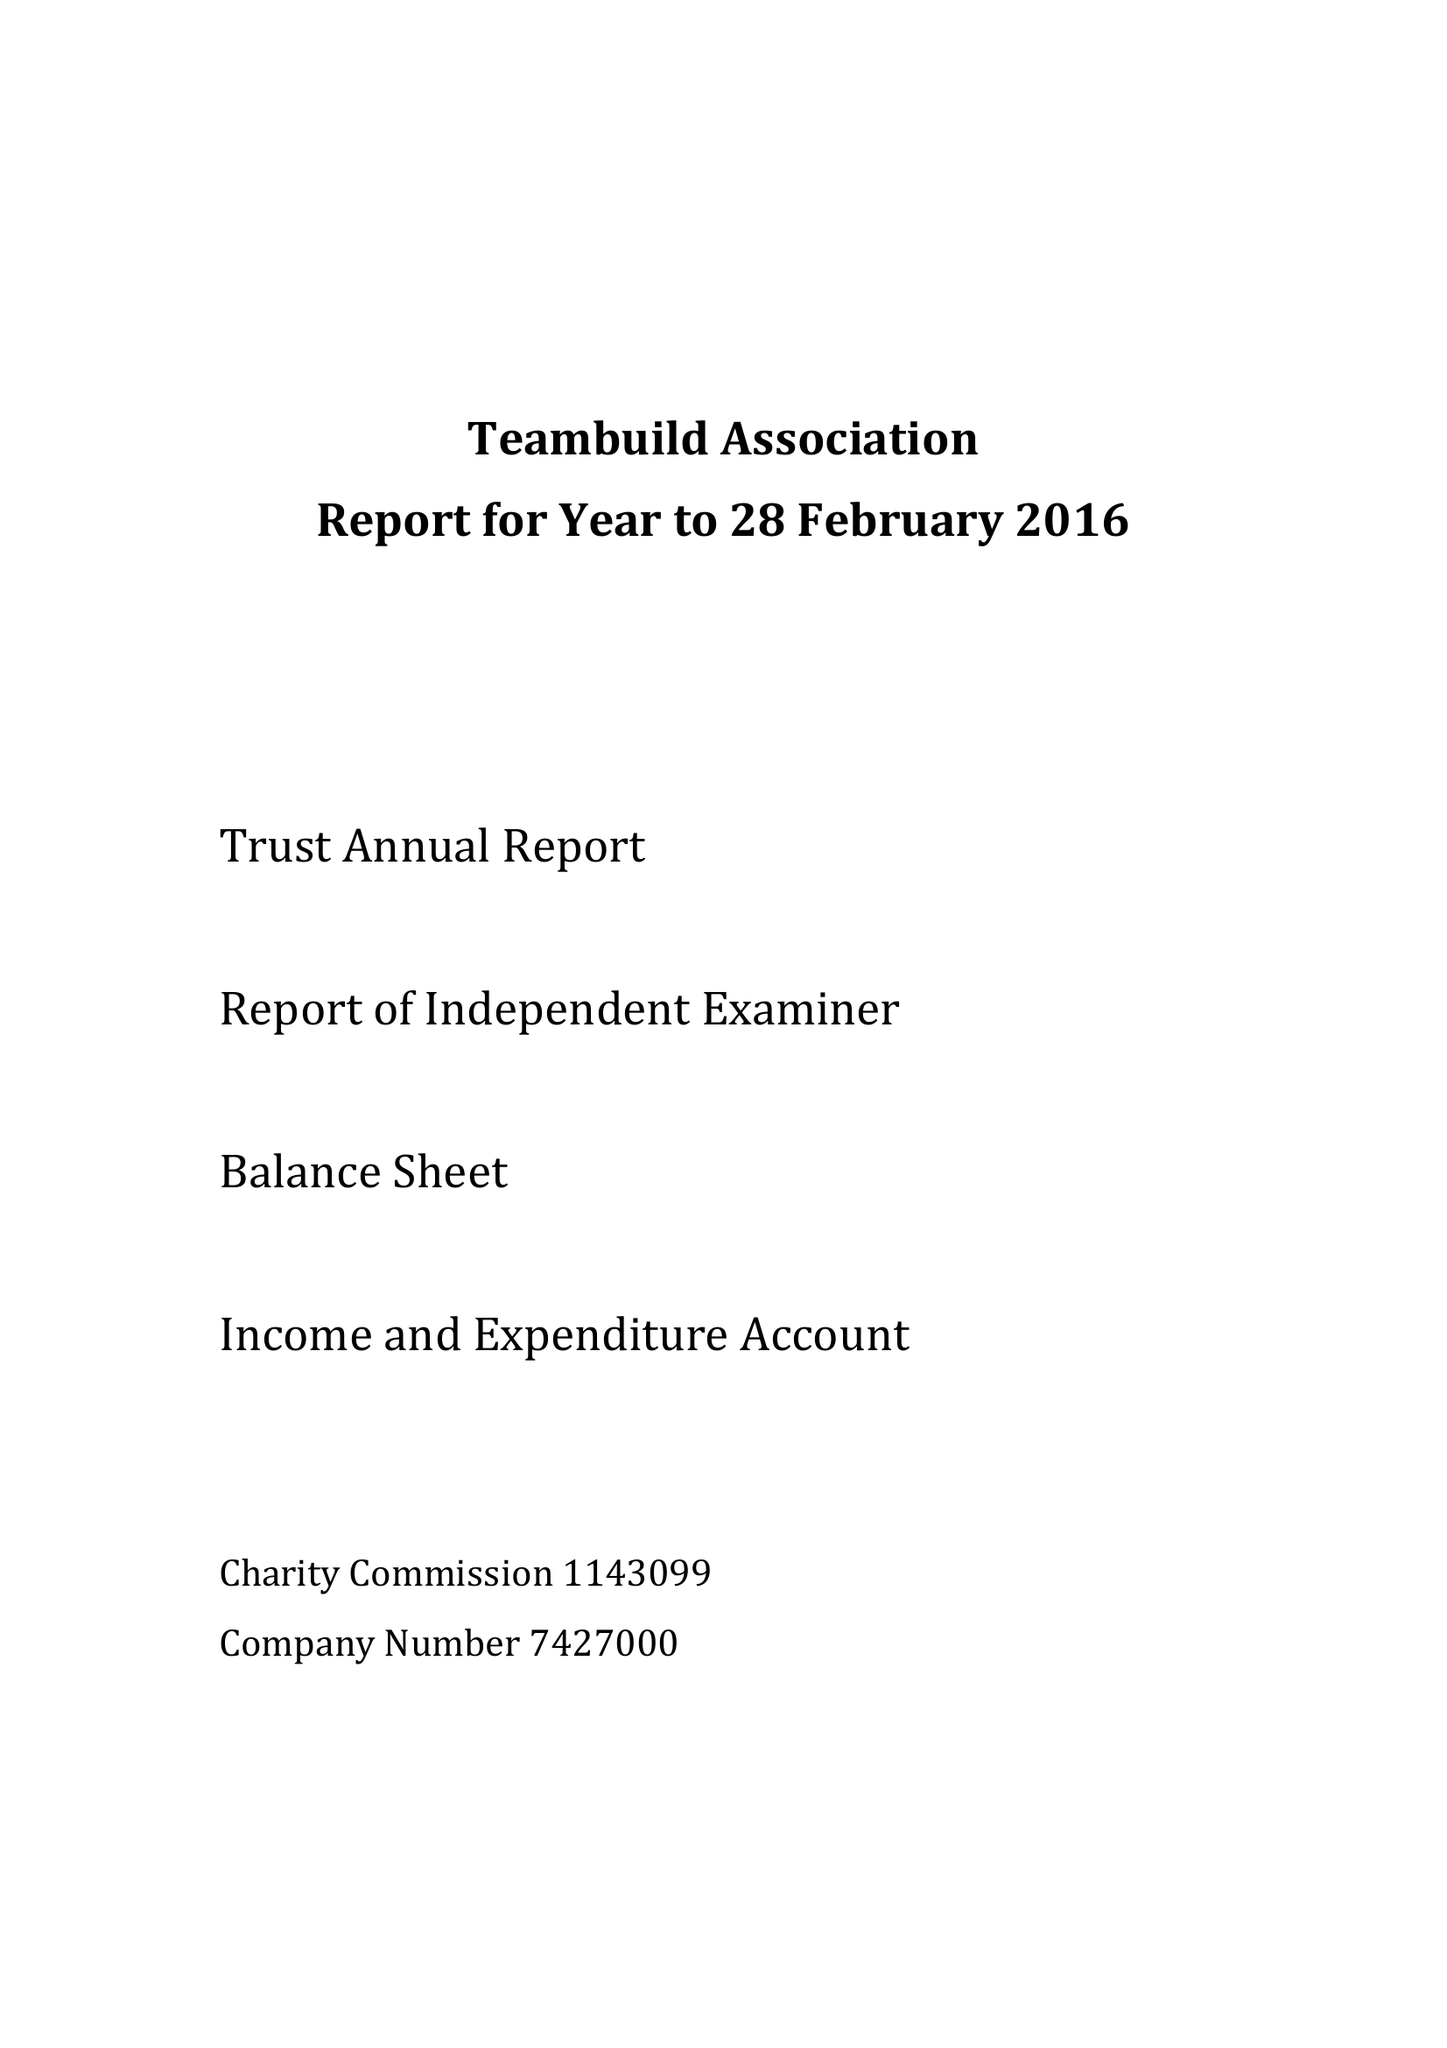What is the value for the address__street_line?
Answer the question using a single word or phrase. None 